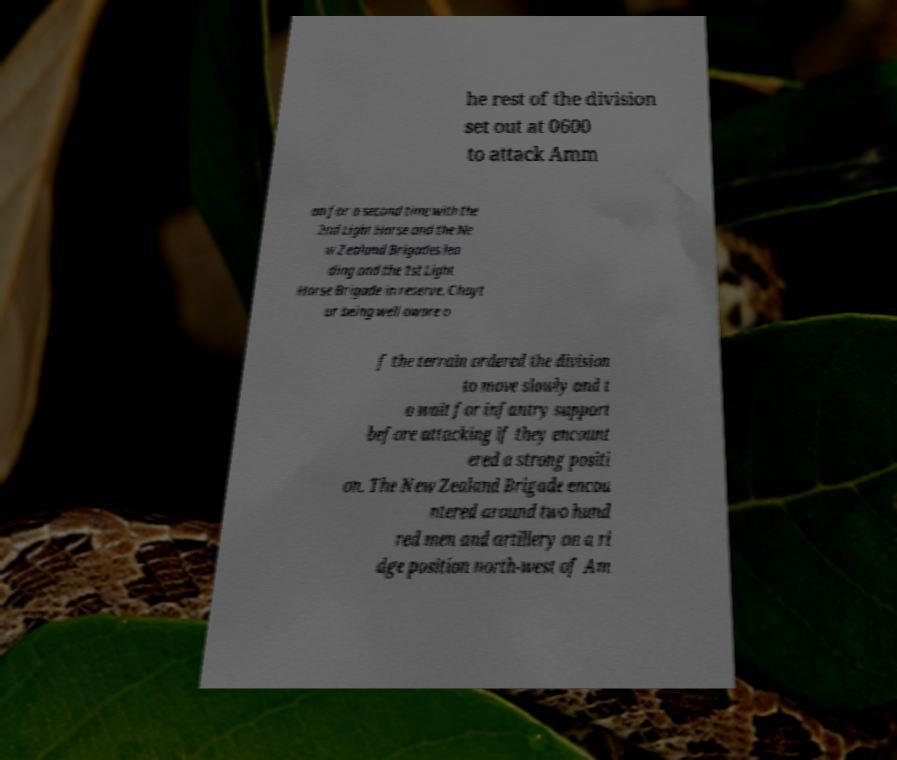I need the written content from this picture converted into text. Can you do that? he rest of the division set out at 0600 to attack Amm an for a second time with the 2nd Light Horse and the Ne w Zealand Brigades lea ding and the 1st Light Horse Brigade in reserve. Chayt or being well aware o f the terrain ordered the division to move slowly and t o wait for infantry support before attacking if they encount ered a strong positi on. The New Zealand Brigade encou ntered around two hund red men and artillery on a ri dge position north-west of Am 